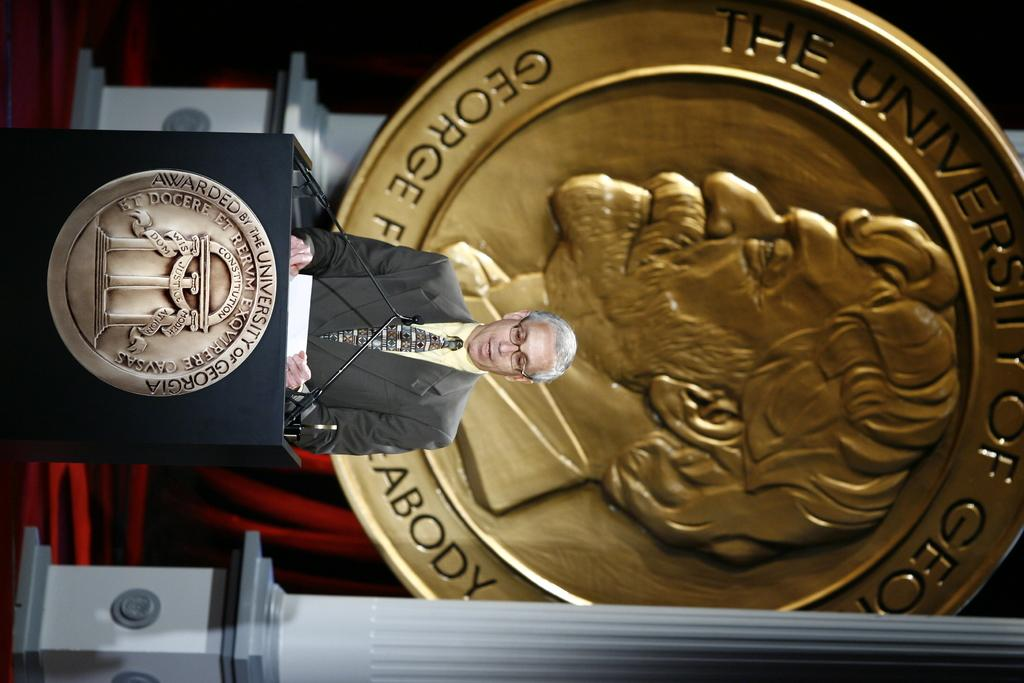<image>
Provide a brief description of the given image. a large gold disc on its side with the word George readable. 